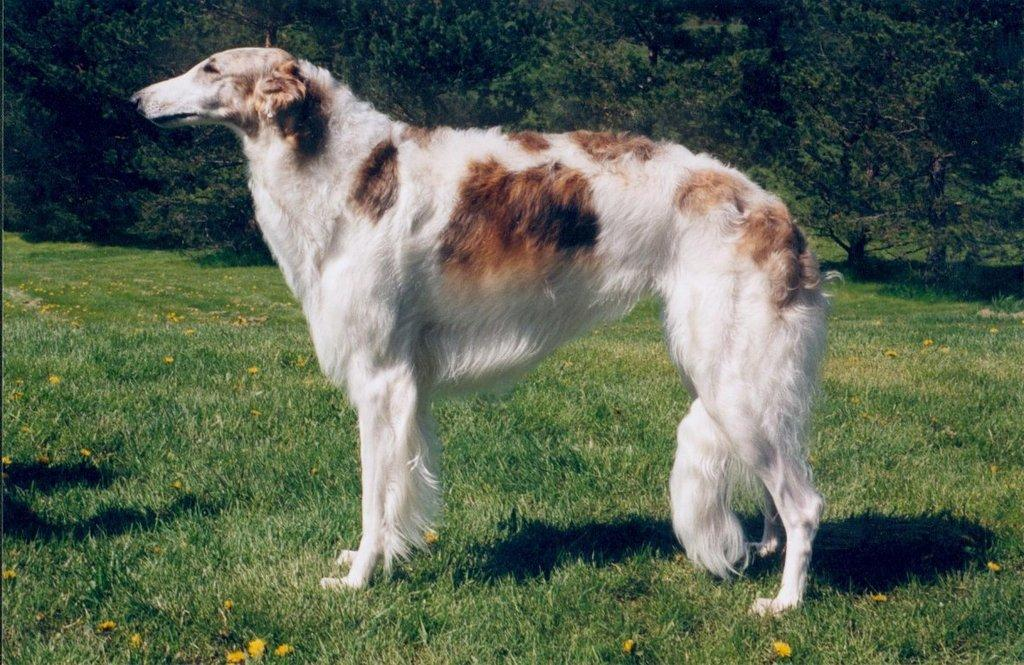What type of vegetation is at the bottom of the image? There is grass and trees at the bottom of the image. Are there any other trees visible in the image? Yes, there are trees at the top of the image as well. What is the main subject in the middle of the image? There is a dog in the middle of the image. What colors can be seen on the dog? The dog is white and brown in color. What type of book is the dog reading in the image? There is no book present in the image; it features a dog in the middle of the image. Is there any evidence of a crime scene in the image? There is no mention or indication of a crime scene in the image. 